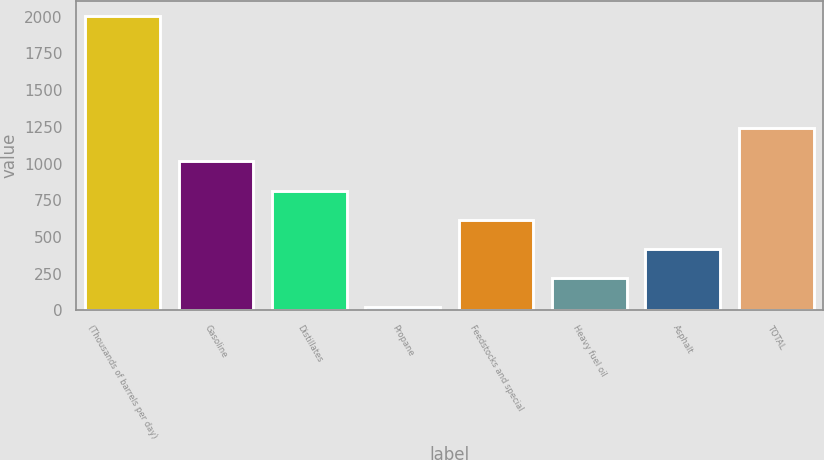Convert chart to OTSL. <chart><loc_0><loc_0><loc_500><loc_500><bar_chart><fcel>(Thousands of barrels per day)<fcel>Gasoline<fcel>Distillates<fcel>Propane<fcel>Feedstocks and special<fcel>Heavy fuel oil<fcel>Asphalt<fcel>TOTAL<nl><fcel>2007<fcel>1015<fcel>816.6<fcel>23<fcel>618.2<fcel>221.4<fcel>419.8<fcel>1239<nl></chart> 